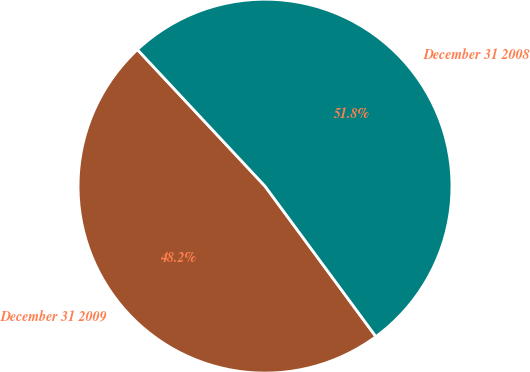Convert chart to OTSL. <chart><loc_0><loc_0><loc_500><loc_500><pie_chart><fcel>December 31 2009<fcel>December 31 2008<nl><fcel>48.15%<fcel>51.85%<nl></chart> 